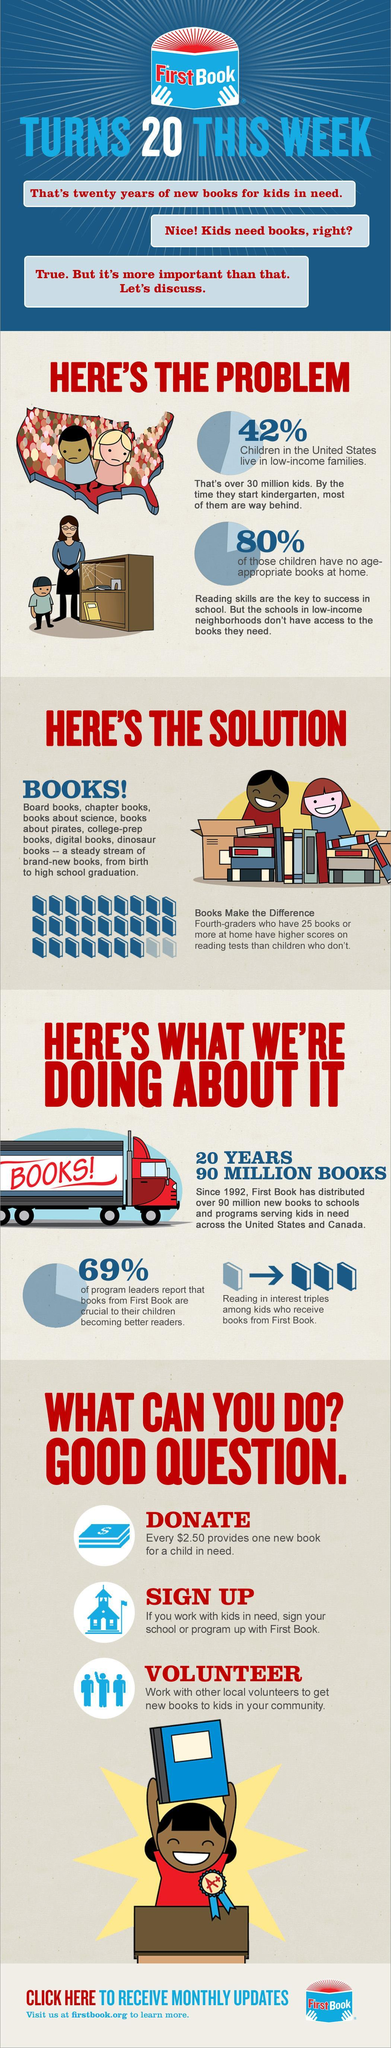What percentage of children have age-appropriate books at home?
Answer the question with a short phrase. 20% What percentage of children in the United States live not in low-income families? 58% 